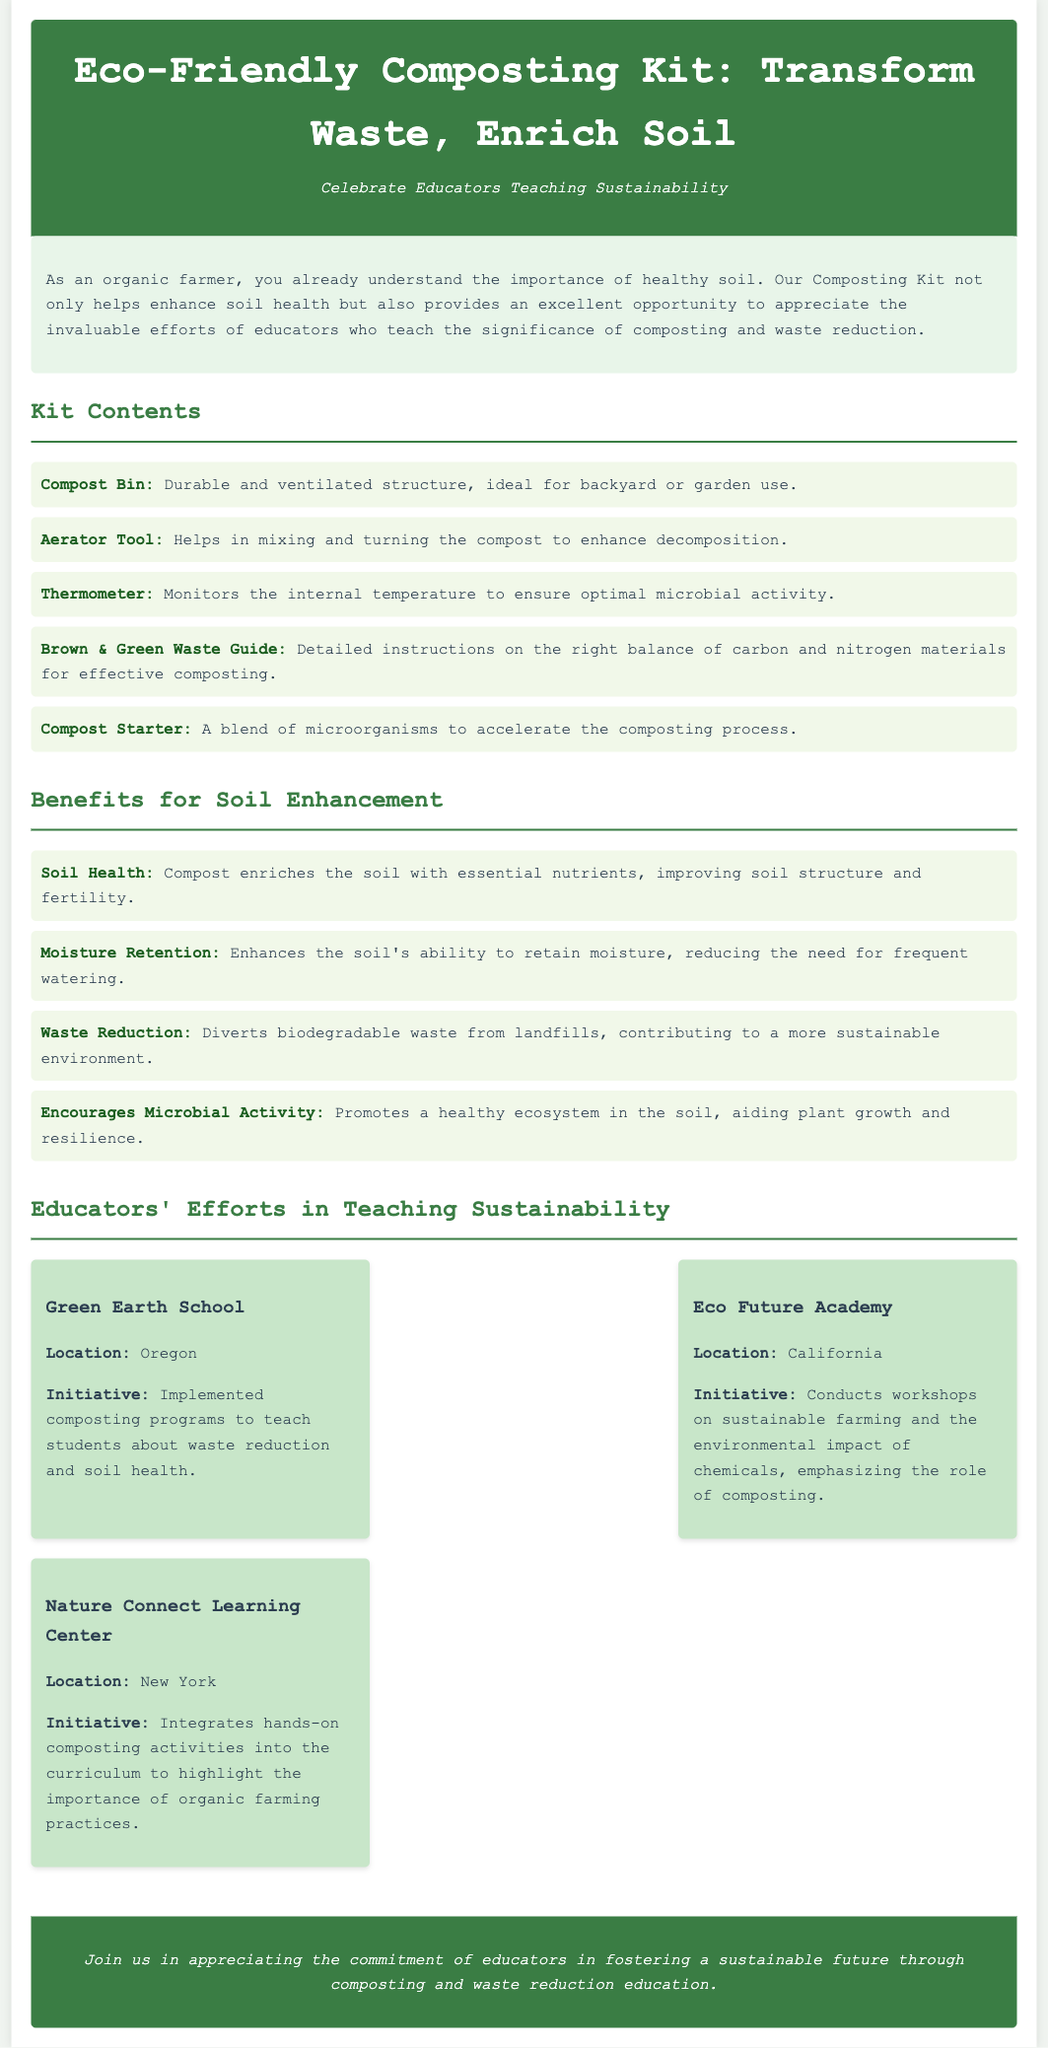What is the title of the product? The title is found in the header section of the document, stating the main subject of the product.
Answer: Eco-Friendly Composting Kit: Transform Waste, Enrich Soil How many tools are included in the kit? The kit contents section lists five items included in the composting kit.
Answer: Five What does the Compost Starter contain? The contents section describes the Compost Starter item and its purpose within the kit.
Answer: A blend of microorganisms What is one benefit of composting for soil health? The benefits section lists multiple advantages of composting, specifically for improving soil quality.
Answer: Nutrients Which educator is located in California? The educators' section lists educators along with their locations, mentioning which ones are in California.
Answer: Eco Future Academy What is the main focus of Green Earth School's initiative? The initiative of this particular educator focuses on what educational programs they implemented, which is provided in the document.
Answer: Composting programs How does composting contribute to sustainability? The benefits section indicates that composting aids in waste management, detailing its role in a sustainable environment.
Answer: Waste reduction Which location integrates hands-on composting activities? The document specifies which organization's initiative involves practical composting activities for their curriculum.
Answer: Nature Connect Learning Center What educational approach does Eco Future Academy emphasize? The initiative of the educator outlines their methods and focus areas, including workshops conducted regarding specific topics.
Answer: Sustainable farming 